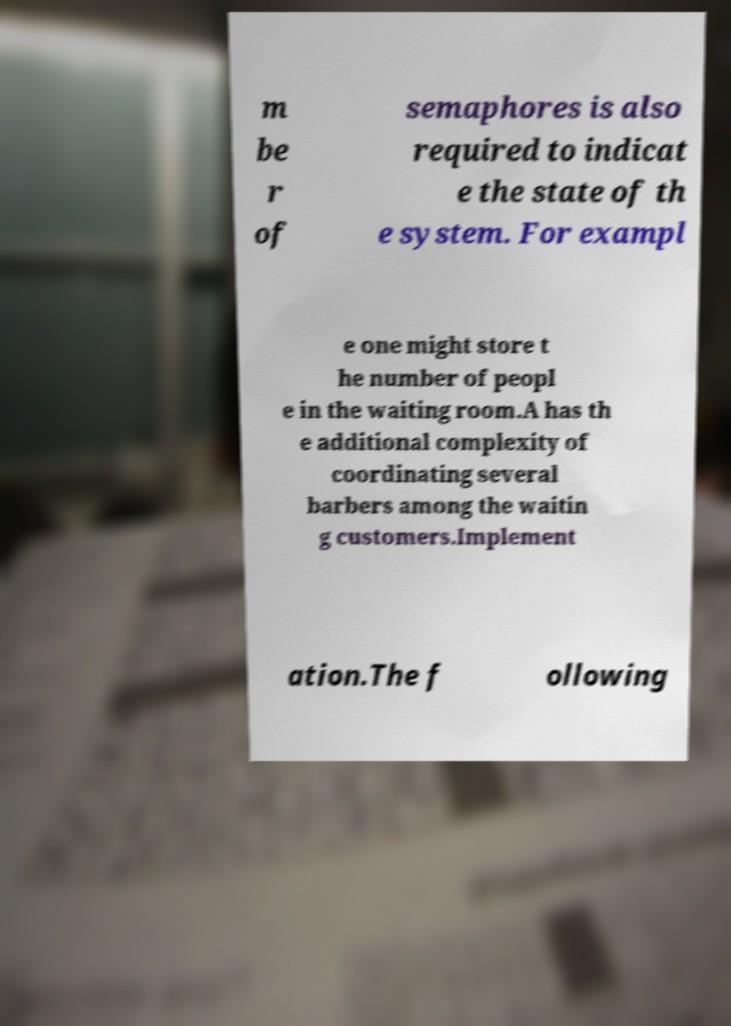Please identify and transcribe the text found in this image. m be r of semaphores is also required to indicat e the state of th e system. For exampl e one might store t he number of peopl e in the waiting room.A has th e additional complexity of coordinating several barbers among the waitin g customers.Implement ation.The f ollowing 